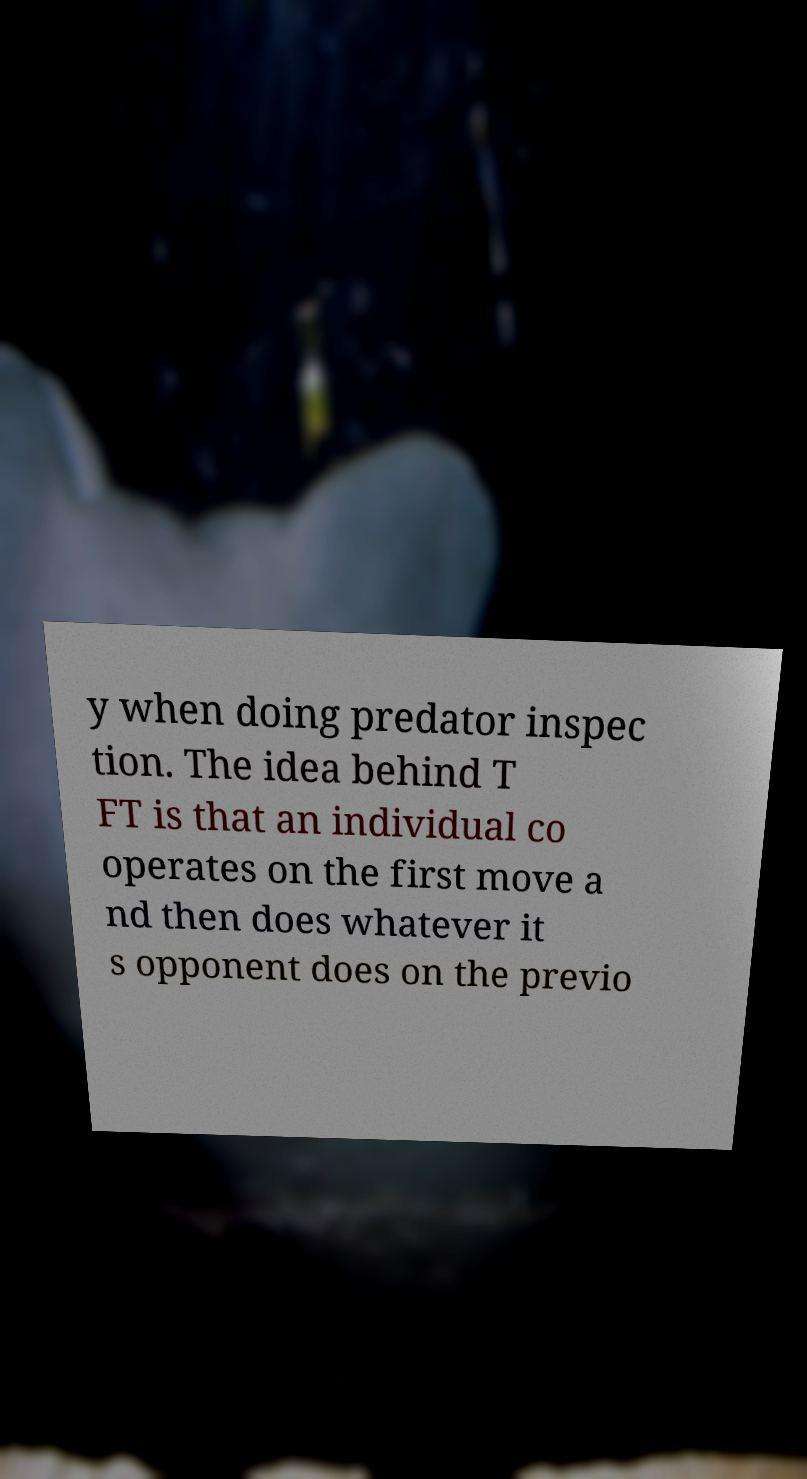For documentation purposes, I need the text within this image transcribed. Could you provide that? y when doing predator inspec tion. The idea behind T FT is that an individual co operates on the first move a nd then does whatever it s opponent does on the previo 